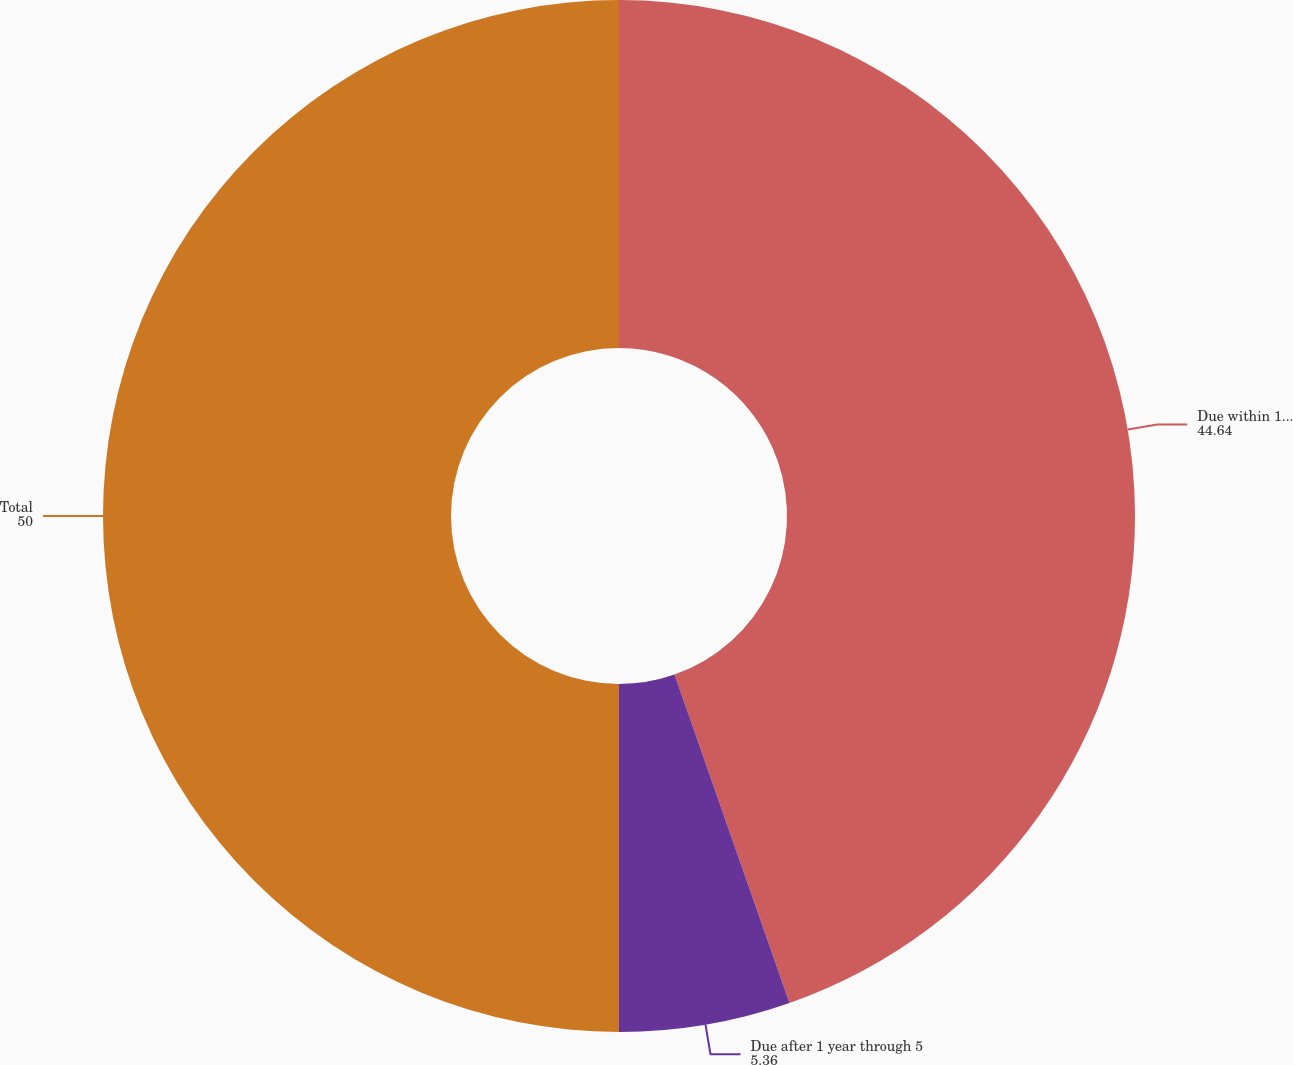<chart> <loc_0><loc_0><loc_500><loc_500><pie_chart><fcel>Due within 1 year<fcel>Due after 1 year through 5<fcel>Total<nl><fcel>44.64%<fcel>5.36%<fcel>50.0%<nl></chart> 